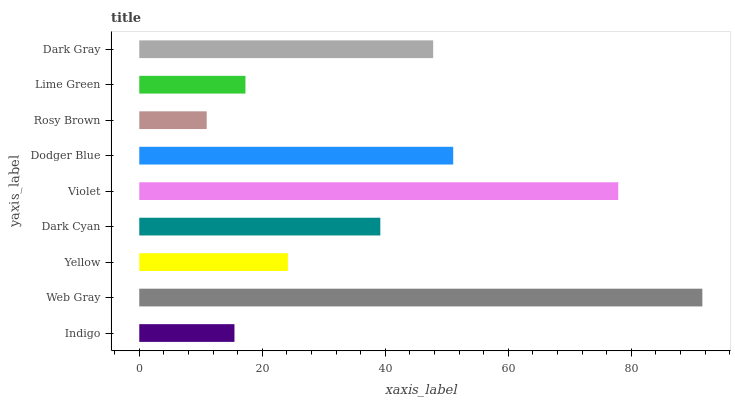Is Rosy Brown the minimum?
Answer yes or no. Yes. Is Web Gray the maximum?
Answer yes or no. Yes. Is Yellow the minimum?
Answer yes or no. No. Is Yellow the maximum?
Answer yes or no. No. Is Web Gray greater than Yellow?
Answer yes or no. Yes. Is Yellow less than Web Gray?
Answer yes or no. Yes. Is Yellow greater than Web Gray?
Answer yes or no. No. Is Web Gray less than Yellow?
Answer yes or no. No. Is Dark Cyan the high median?
Answer yes or no. Yes. Is Dark Cyan the low median?
Answer yes or no. Yes. Is Rosy Brown the high median?
Answer yes or no. No. Is Yellow the low median?
Answer yes or no. No. 